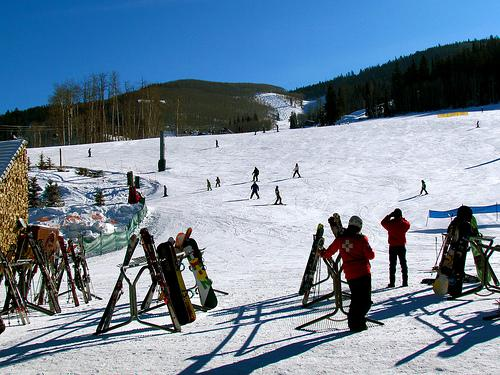Question: where was this photo taken?
Choices:
A. At the hotel.
B. At a ski resort.
C. At the Convention Center.
D. At the theater.
Answer with the letter. Answer: B Question: what is on the ground?
Choices:
A. Snow.
B. Grass.
C. Dirt.
D. Concrete.
Answer with the letter. Answer: A Question: who is the man in the middle?
Choices:
A. A city employee.
B. A policeman.
C. A rescue worker.
D. A passerby.
Answer with the letter. Answer: C Question: when was this photo taken?
Choices:
A. At night.
B. At sunrise.
C. In the morning.
D. During the day.
Answer with the letter. Answer: D 